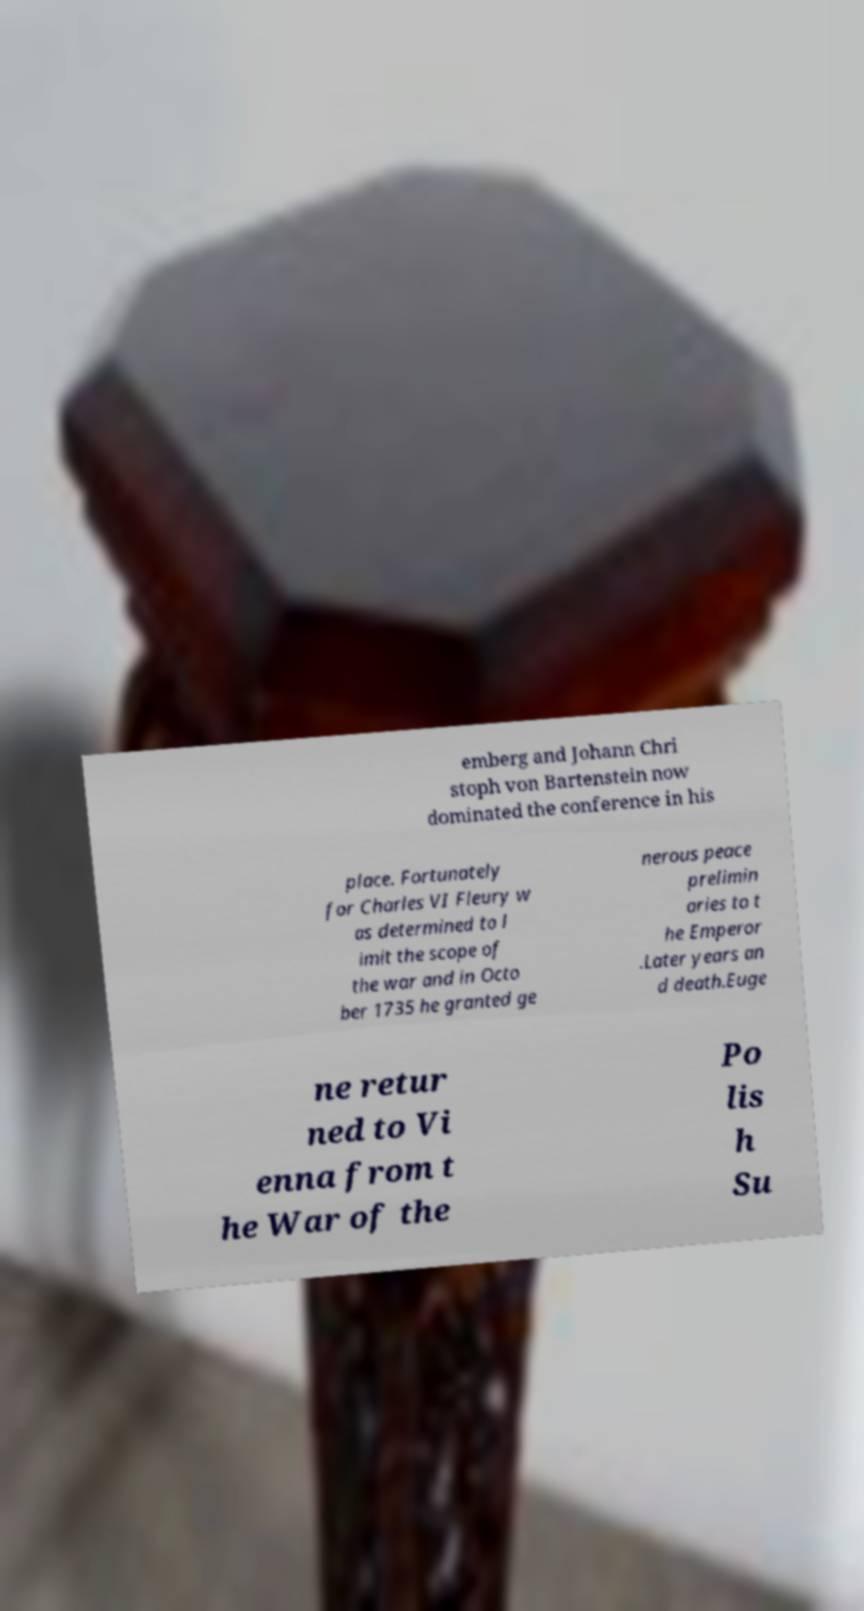Could you assist in decoding the text presented in this image and type it out clearly? emberg and Johann Chri stoph von Bartenstein now dominated the conference in his place. Fortunately for Charles VI Fleury w as determined to l imit the scope of the war and in Octo ber 1735 he granted ge nerous peace prelimin aries to t he Emperor .Later years an d death.Euge ne retur ned to Vi enna from t he War of the Po lis h Su 